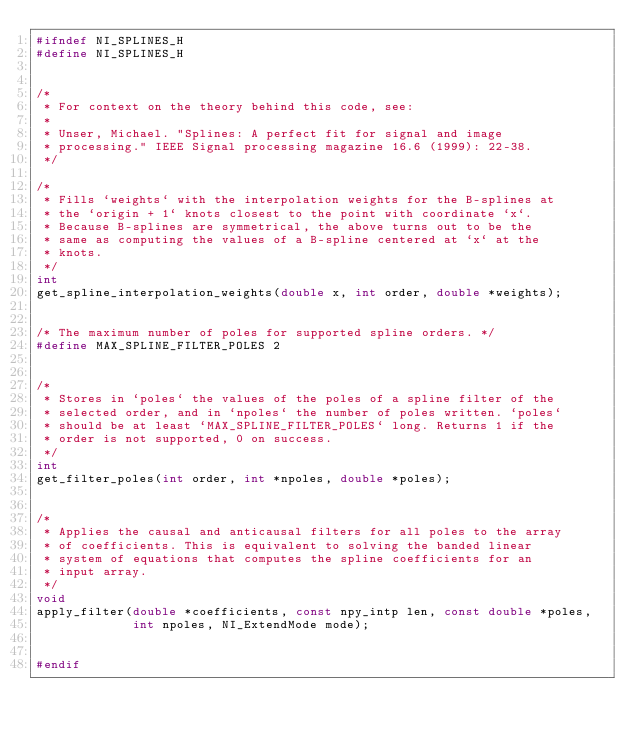Convert code to text. <code><loc_0><loc_0><loc_500><loc_500><_C_>#ifndef NI_SPLINES_H
#define NI_SPLINES_H


/*
 * For context on the theory behind this code, see:
 *
 * Unser, Michael. "Splines: A perfect fit for signal and image
 * processing." IEEE Signal processing magazine 16.6 (1999): 22-38.
 */

/*
 * Fills `weights` with the interpolation weights for the B-splines at
 * the `origin + 1` knots closest to the point with coordinate `x`.
 * Because B-splines are symmetrical, the above turns out to be the
 * same as computing the values of a B-spline centered at `x` at the
 * knots.
 */
int
get_spline_interpolation_weights(double x, int order, double *weights);


/* The maximum number of poles for supported spline orders. */
#define MAX_SPLINE_FILTER_POLES 2


/*
 * Stores in `poles` the values of the poles of a spline filter of the
 * selected order, and in `npoles` the number of poles written. `poles`
 * should be at least `MAX_SPLINE_FILTER_POLES` long. Returns 1 if the
 * order is not supported, 0 on success.
 */
int
get_filter_poles(int order, int *npoles, double *poles);


/*
 * Applies the causal and anticausal filters for all poles to the array
 * of coefficients. This is equivalent to solving the banded linear
 * system of equations that computes the spline coefficients for an
 * input array.
 */
void
apply_filter(double *coefficients, const npy_intp len, const double *poles,
             int npoles, NI_ExtendMode mode);


#endif</code> 